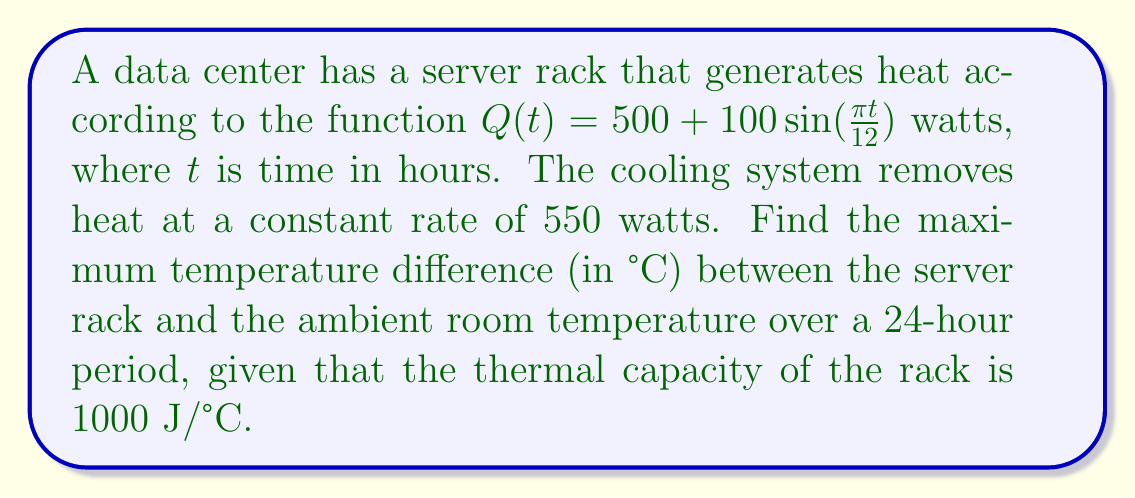What is the answer to this math problem? 1) The net heat accumulation rate is the difference between heat generation and removal:
   $$\frac{dQ}{dt} = Q(t) - 550 = 500 + 100\sin(\frac{\pi t}{12}) - 550 = 100\sin(\frac{\pi t}{12}) - 50$$

2) The temperature change is related to heat accumulation by the thermal capacity:
   $$\frac{dT}{dt} = \frac{1}{1000}\frac{dQ}{dt} = \frac{1}{10}\sin(\frac{\pi t}{12}) - \frac{1}{20}$$

3) To find the temperature difference, we integrate:
   $$T(t) = \int \frac{dT}{dt} dt = -\frac{12}{10\pi}\cos(\frac{\pi t}{12}) - \frac{t}{20} + C$$

4) The constant C doesn't affect the maximum difference, so we can ignore it.

5) To find the maximum, we differentiate and set to zero:
   $$\frac{dT}{dt} = \frac{1}{10}\sin(\frac{\pi t}{12}) - \frac{1}{20} = 0$$

6) Solving this:
   $$\sin(\frac{\pi t}{12}) = \frac{1}{2}$$
   $$t = \frac{12}{\pi}\arcsin(\frac{1}{2}) \approx 3.82 \text{ or } 12 - 3.82 = 8.18 \text{ hours}$$

7) The maximum temperature difference occurs at t ≈ 3.82 hours:
   $$T_{max} = -\frac{12}{10\pi}\cos(\frac{\pi \cdot 3.82}{12}) - \frac{3.82}{20} \approx 1.15°C$$

8) The minimum occurs at t ≈ 8.18 hours:
   $$T_{min} = -\frac{12}{10\pi}\cos(\frac{\pi \cdot 8.18}{12}) - \frac{8.18}{20} \approx -1.15°C$$

9) The maximum temperature difference is:
   $$T_{max} - T_{min} \approx 1.15 - (-1.15) = 2.3°C$$
Answer: 2.3°C 